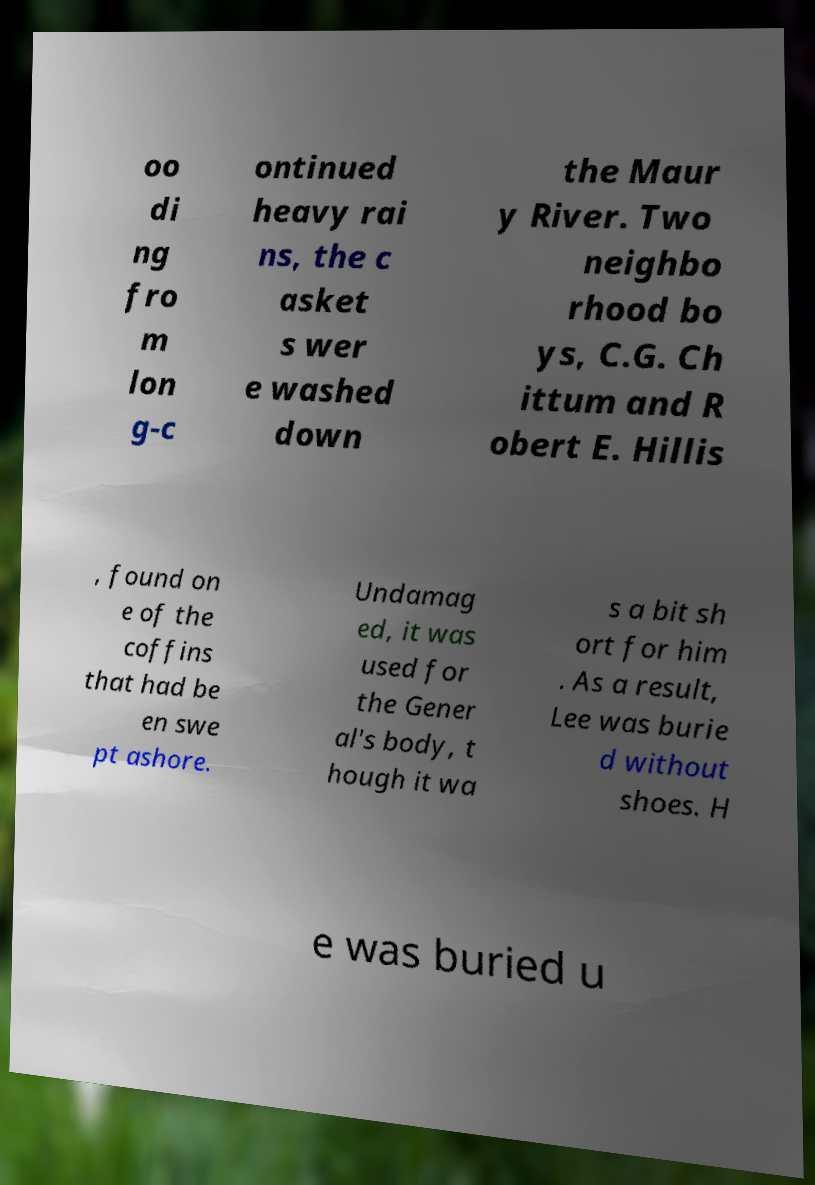There's text embedded in this image that I need extracted. Can you transcribe it verbatim? oo di ng fro m lon g-c ontinued heavy rai ns, the c asket s wer e washed down the Maur y River. Two neighbo rhood bo ys, C.G. Ch ittum and R obert E. Hillis , found on e of the coffins that had be en swe pt ashore. Undamag ed, it was used for the Gener al's body, t hough it wa s a bit sh ort for him . As a result, Lee was burie d without shoes. H e was buried u 